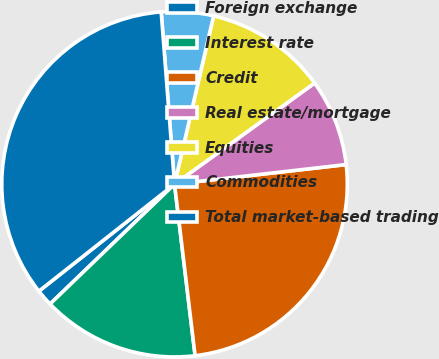Convert chart to OTSL. <chart><loc_0><loc_0><loc_500><loc_500><pie_chart><fcel>Foreign exchange<fcel>Interest rate<fcel>Credit<fcel>Real estate/mortgage<fcel>Equities<fcel>Commodities<fcel>Total market-based trading<nl><fcel>1.57%<fcel>14.7%<fcel>24.91%<fcel>8.14%<fcel>11.42%<fcel>4.86%<fcel>34.4%<nl></chart> 